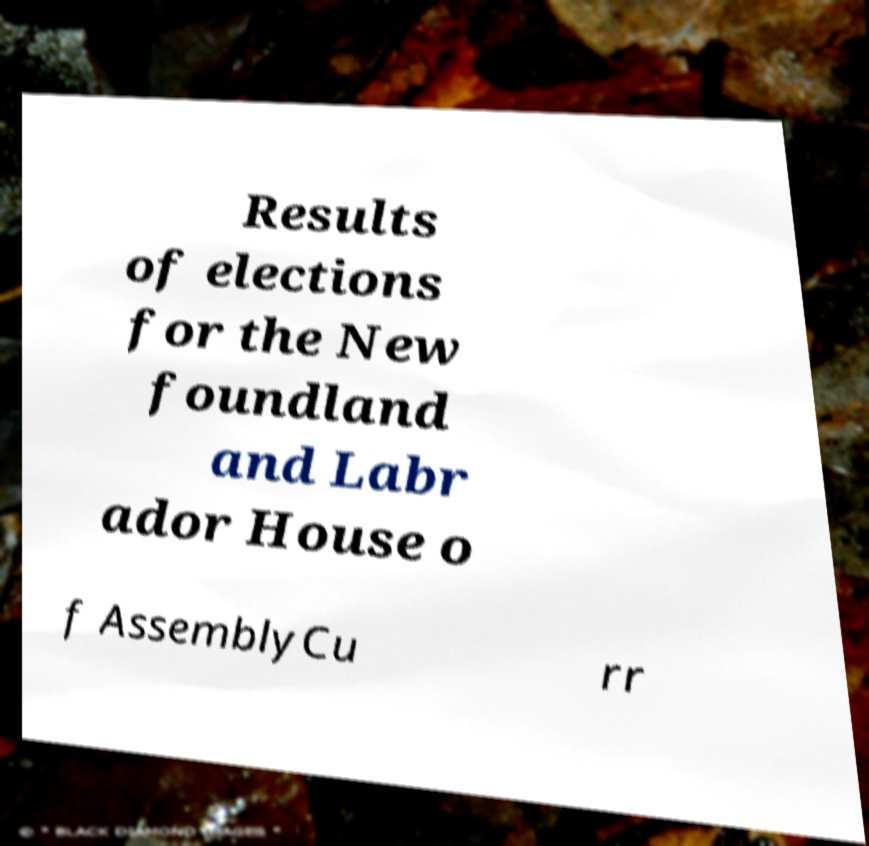Could you extract and type out the text from this image? Results of elections for the New foundland and Labr ador House o f AssemblyCu rr 